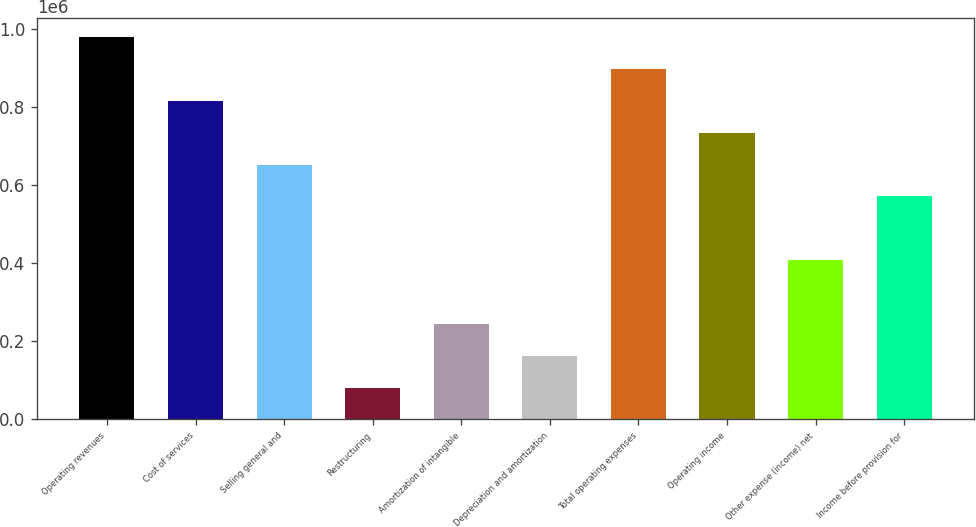Convert chart. <chart><loc_0><loc_0><loc_500><loc_500><bar_chart><fcel>Operating revenues<fcel>Cost of services<fcel>Selling general and<fcel>Restructuring<fcel>Amortization of intangible<fcel>Depreciation and amortization<fcel>Total operating expenses<fcel>Operating income<fcel>Other expense (income) net<fcel>Income before provision for<nl><fcel>979703<fcel>816419<fcel>653135<fcel>81642.7<fcel>244926<fcel>163285<fcel>898061<fcel>734777<fcel>408210<fcel>571494<nl></chart> 